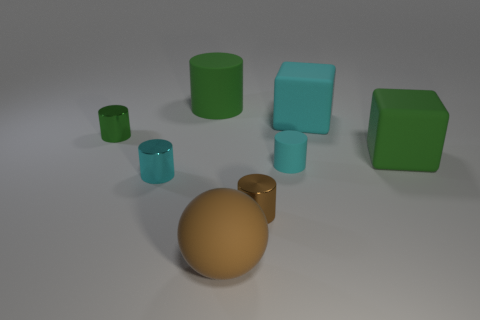Subtract all green rubber cylinders. How many cylinders are left? 4 Subtract all brown cylinders. How many cylinders are left? 4 Subtract 1 cylinders. How many cylinders are left? 4 Subtract all purple cylinders. Subtract all yellow blocks. How many cylinders are left? 5 Subtract all blocks. How many objects are left? 6 Add 1 big gray metallic cylinders. How many objects exist? 9 Add 2 small brown objects. How many small brown objects are left? 3 Add 4 tiny shiny objects. How many tiny shiny objects exist? 7 Subtract 0 red blocks. How many objects are left? 8 Subtract all rubber objects. Subtract all large rubber spheres. How many objects are left? 2 